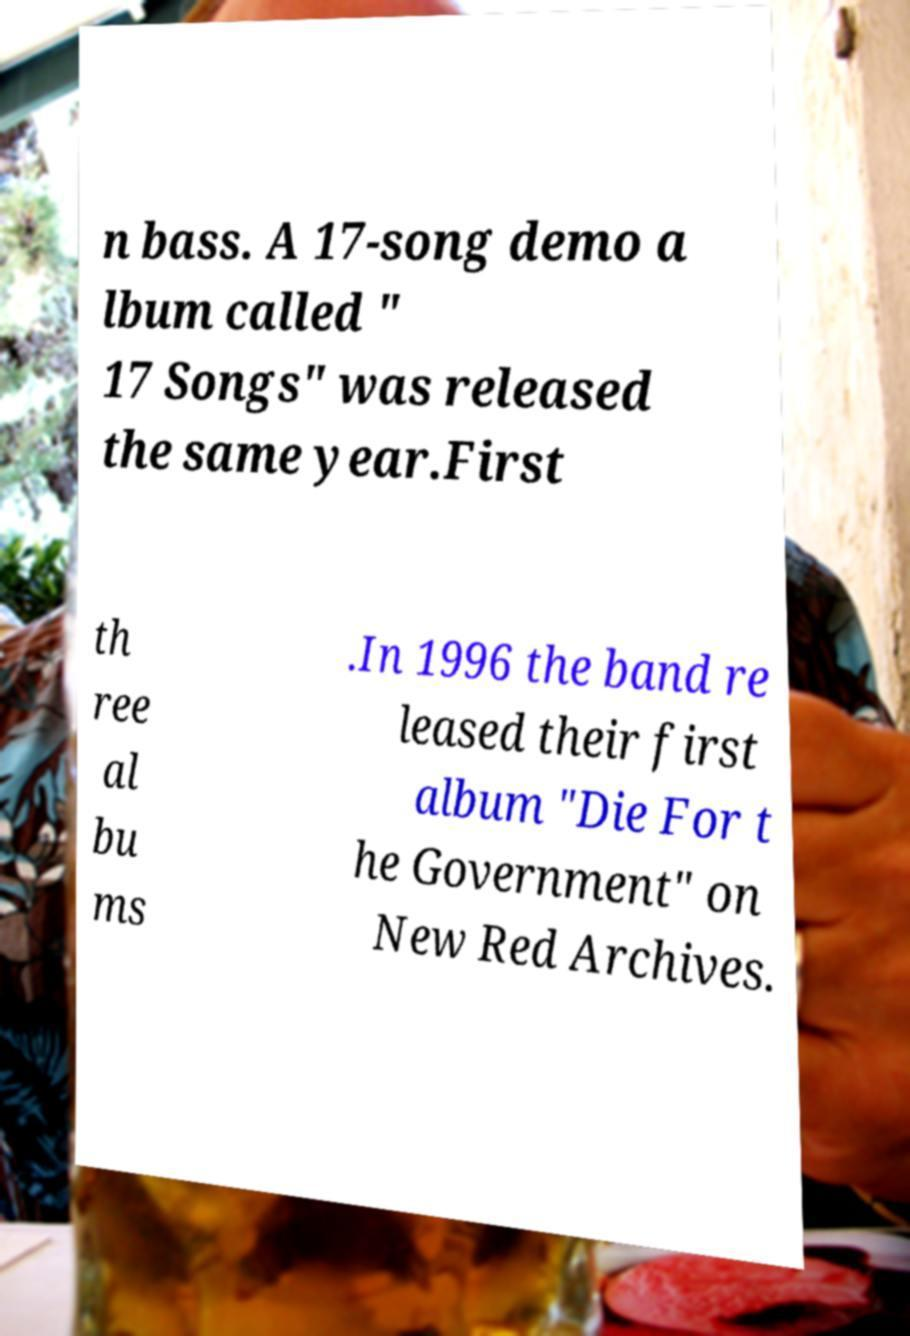For documentation purposes, I need the text within this image transcribed. Could you provide that? n bass. A 17-song demo a lbum called " 17 Songs" was released the same year.First th ree al bu ms .In 1996 the band re leased their first album "Die For t he Government" on New Red Archives. 